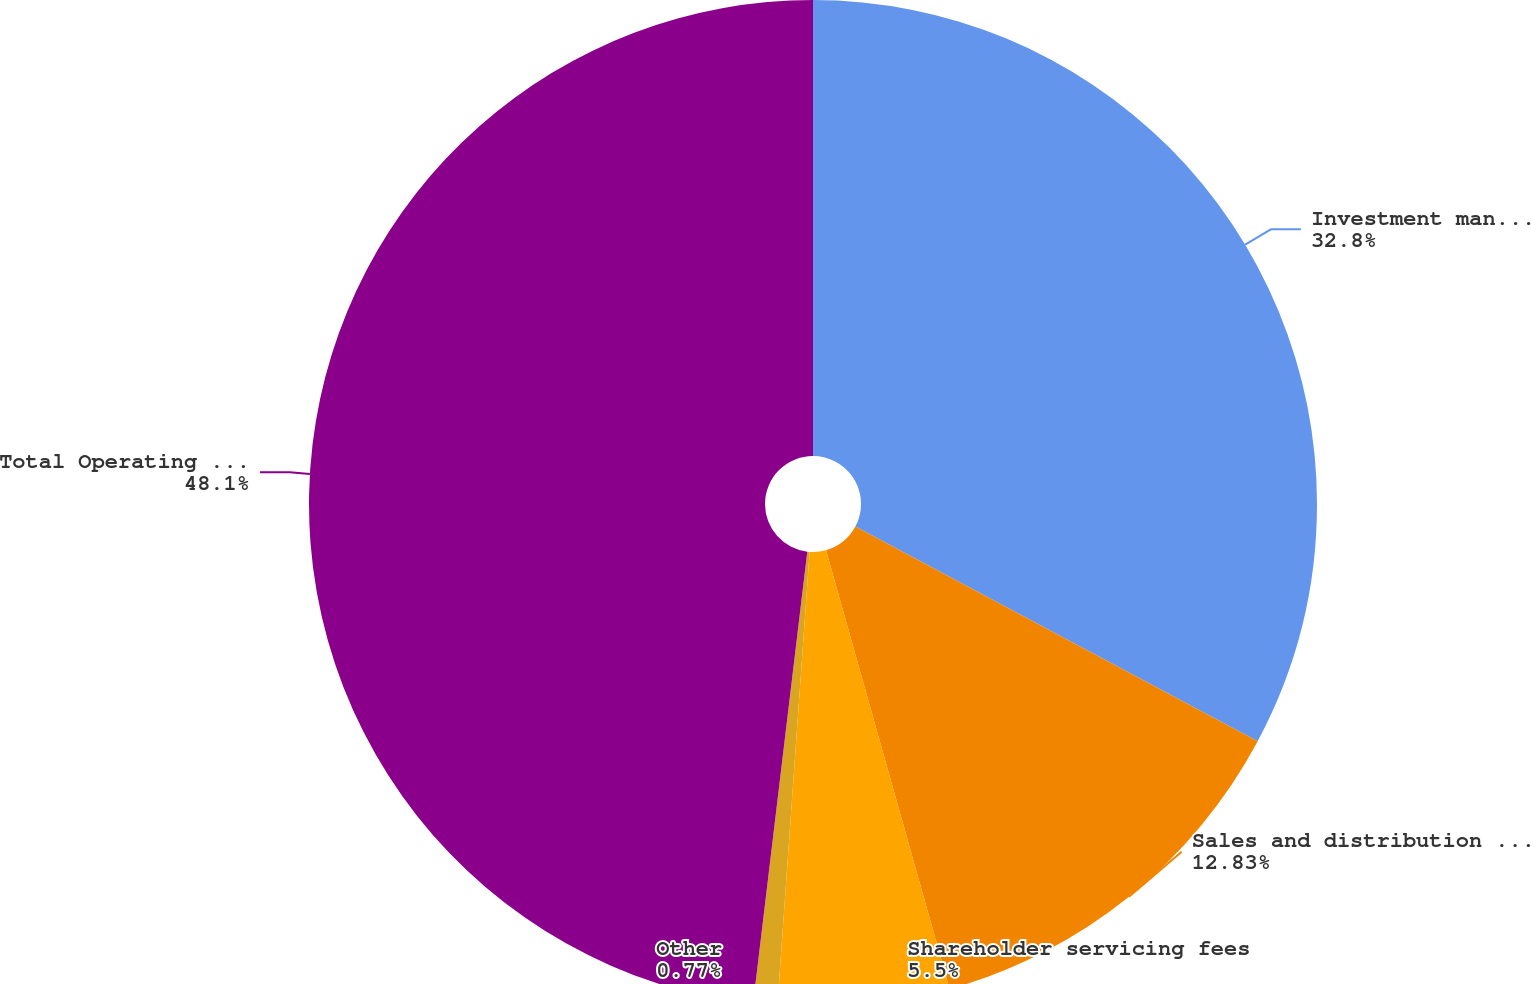<chart> <loc_0><loc_0><loc_500><loc_500><pie_chart><fcel>Investment management fees<fcel>Sales and distribution fees<fcel>Shareholder servicing fees<fcel>Other<fcel>Total Operating Revenues<nl><fcel>32.8%<fcel>12.83%<fcel>5.5%<fcel>0.77%<fcel>48.1%<nl></chart> 